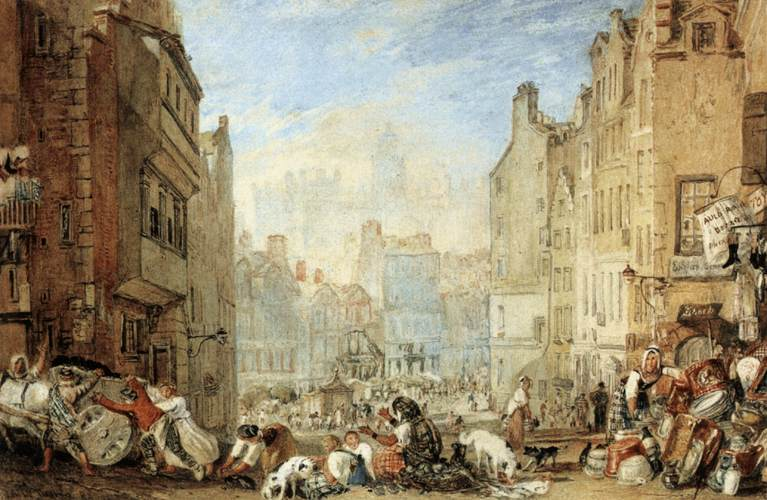Describe the following image. The image portrays a bustling street scene in a European city. The cityscape is dominated by tall buildings that stand shoulder to shoulder, their close proximity creating a sense of density and urban life. The street below teems with life, populated by numerous people and animals, adding a dynamic element to the otherwise static architecture.

The color palette of the painting is primarily composed of earth tones, lending a warm and inviting atmosphere to the scene. Pops of blue in the sky provide a pleasing contrast, breaking the monotony of the earthy hues.

The art style leans towards realism, with meticulous attention to detail evident in the rendering of the buildings and the figures. The genre of the painting can be classified as landscape, as it captures a slice of life in a city, presenting a wide view of its architecture and inhabitants. The artist's skillful use of color, light, and shadow brings depth and dimension to the scene, making it a captivating piece of art. 